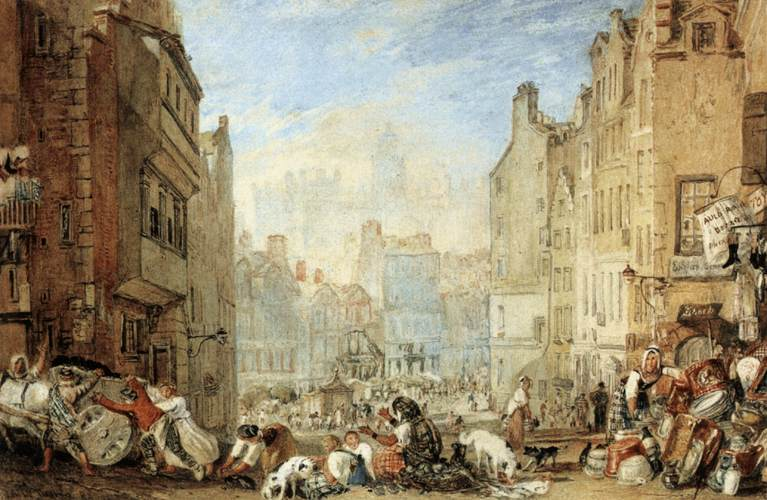Describe the following image. The image portrays a bustling street scene in a European city. The cityscape is dominated by tall buildings that stand shoulder to shoulder, their close proximity creating a sense of density and urban life. The street below teems with life, populated by numerous people and animals, adding a dynamic element to the otherwise static architecture.

The color palette of the painting is primarily composed of earth tones, lending a warm and inviting atmosphere to the scene. Pops of blue in the sky provide a pleasing contrast, breaking the monotony of the earthy hues.

The art style leans towards realism, with meticulous attention to detail evident in the rendering of the buildings and the figures. The genre of the painting can be classified as landscape, as it captures a slice of life in a city, presenting a wide view of its architecture and inhabitants. The artist's skillful use of color, light, and shadow brings depth and dimension to the scene, making it a captivating piece of art. 